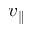<formula> <loc_0><loc_0><loc_500><loc_500>v _ { \| }</formula> 